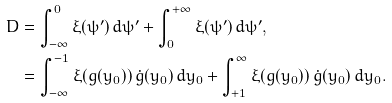<formula> <loc_0><loc_0><loc_500><loc_500>D & = \int _ { - \infty } ^ { 0 } { \xi ( \psi ^ { \prime } ) \, d \psi ^ { \prime } } + \int _ { 0 } ^ { + \infty } { \xi ( \psi ^ { \prime } ) \, d \psi ^ { \prime } } , \\ & = \int _ { - \infty } ^ { - 1 } \xi ( g ( y _ { 0 } ) ) \, { \dot { g } } ( y _ { 0 } ) \, d y _ { 0 } + \int _ { + 1 } ^ { \infty } \xi ( g ( y _ { 0 } ) ) \, { \dot { g } } ( y _ { 0 } ) \, d y _ { 0 } .</formula> 